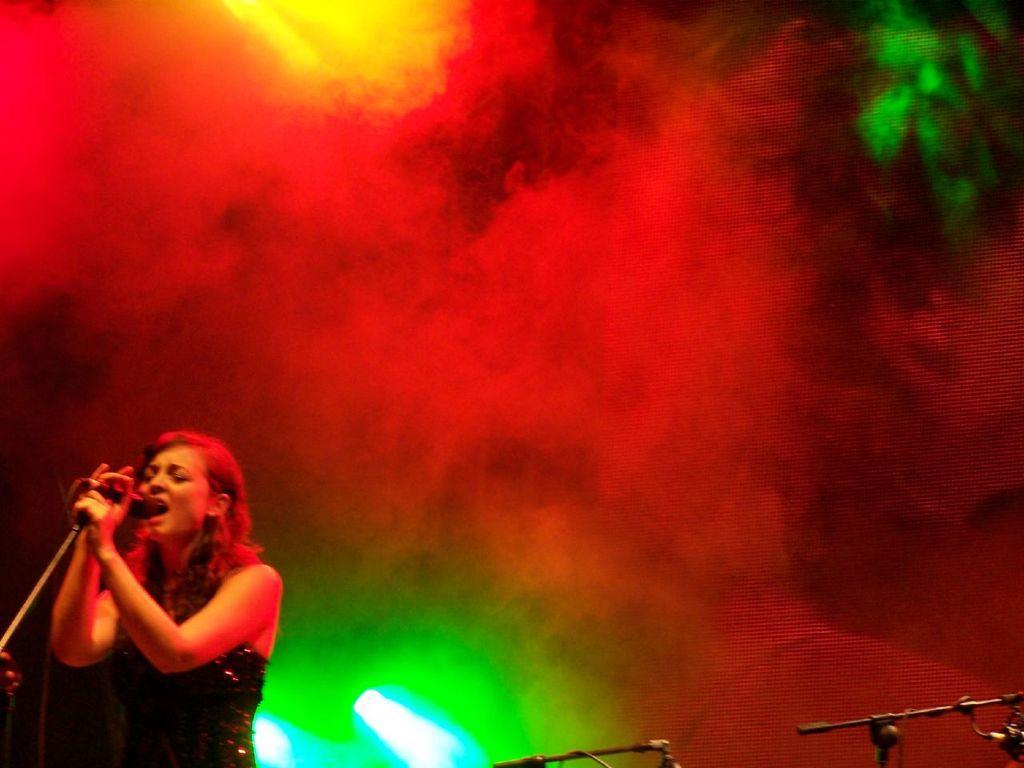Could you give a brief overview of what you see in this image? In this image we can see a woman holding a mic with a stand. We can also see some smoke and lights. 